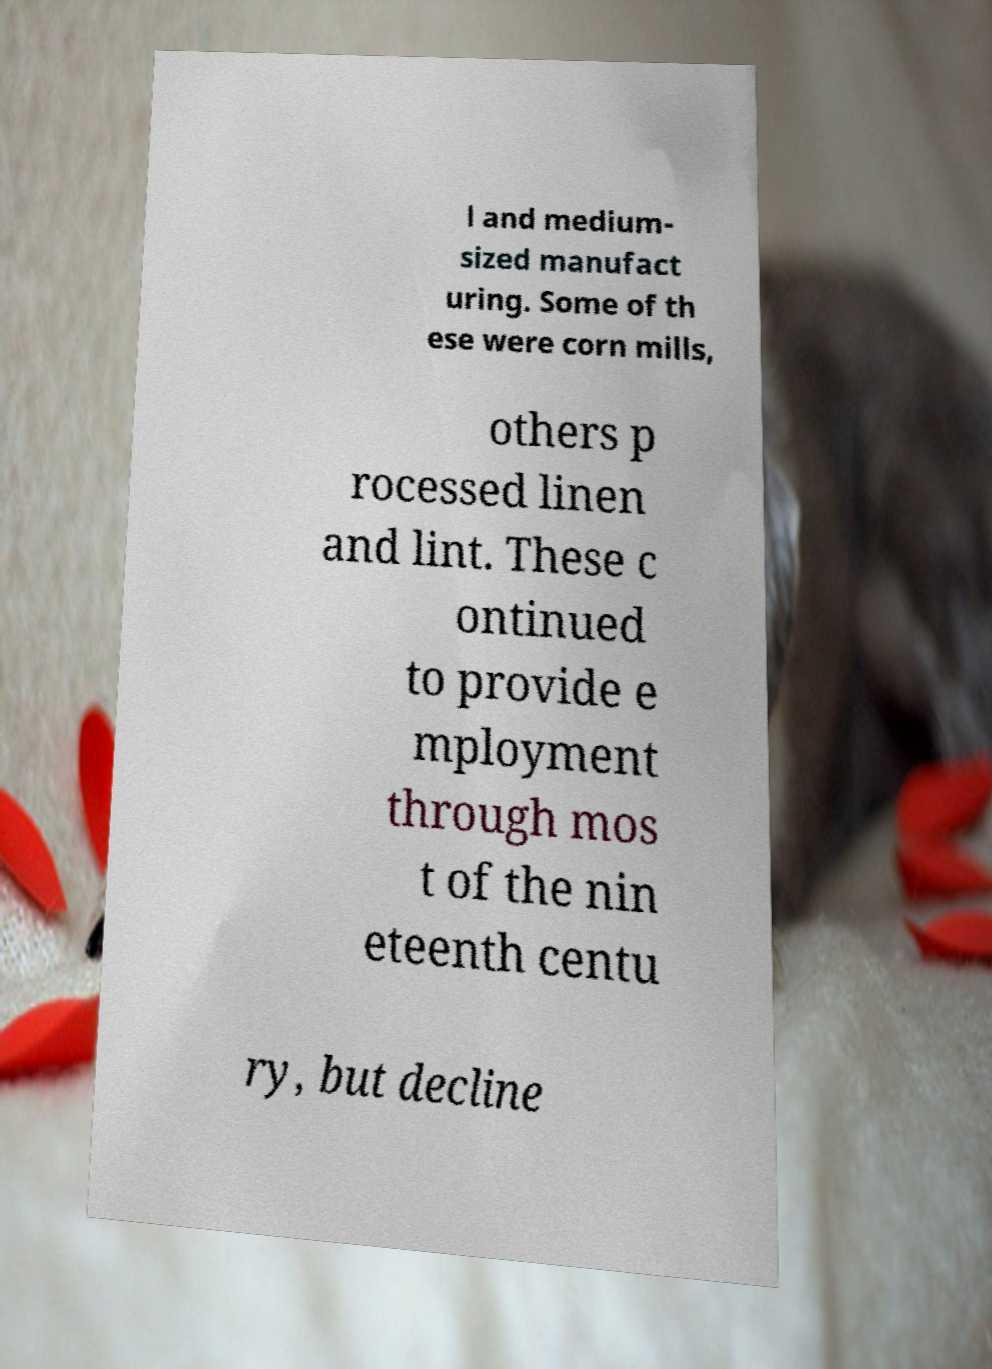There's text embedded in this image that I need extracted. Can you transcribe it verbatim? l and medium- sized manufact uring. Some of th ese were corn mills, others p rocessed linen and lint. These c ontinued to provide e mployment through mos t of the nin eteenth centu ry, but decline 